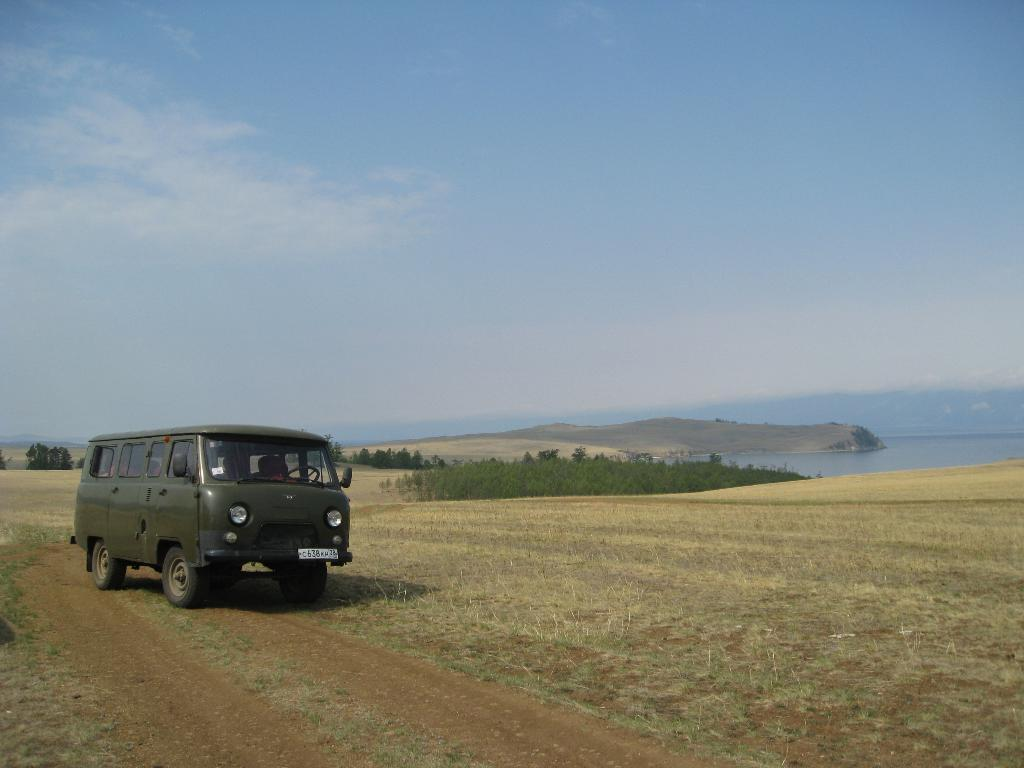What type of vehicle is on the ground in the image? There is a van on the ground in the image. What natural feature can be seen on the right side of the image? There is a river on the right side of the image. What is visible at the top of the image? The sky is visible at the top of the image. What type of vegetation is on the ground in the image? There are small plants on the ground in the image. What color is the feather that is falling from the sky in the image? There is no feather present in the image; it only features a van, a river, the sky, and small plants. 